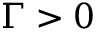<formula> <loc_0><loc_0><loc_500><loc_500>\Gamma > 0</formula> 